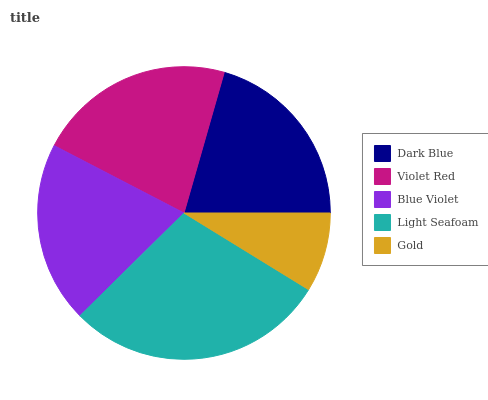Is Gold the minimum?
Answer yes or no. Yes. Is Light Seafoam the maximum?
Answer yes or no. Yes. Is Violet Red the minimum?
Answer yes or no. No. Is Violet Red the maximum?
Answer yes or no. No. Is Violet Red greater than Dark Blue?
Answer yes or no. Yes. Is Dark Blue less than Violet Red?
Answer yes or no. Yes. Is Dark Blue greater than Violet Red?
Answer yes or no. No. Is Violet Red less than Dark Blue?
Answer yes or no. No. Is Dark Blue the high median?
Answer yes or no. Yes. Is Dark Blue the low median?
Answer yes or no. Yes. Is Blue Violet the high median?
Answer yes or no. No. Is Gold the low median?
Answer yes or no. No. 